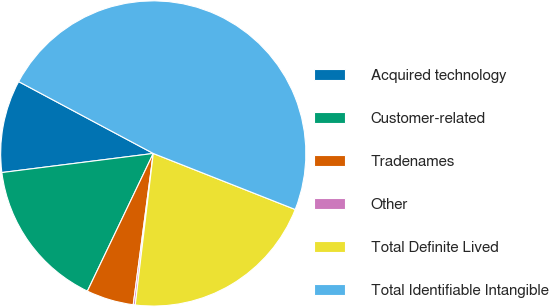<chart> <loc_0><loc_0><loc_500><loc_500><pie_chart><fcel>Acquired technology<fcel>Customer-related<fcel>Tradenames<fcel>Other<fcel>Total Definite Lived<fcel>Total Identifiable Intangible<nl><fcel>9.8%<fcel>15.9%<fcel>5.01%<fcel>0.21%<fcel>20.9%<fcel>48.18%<nl></chart> 